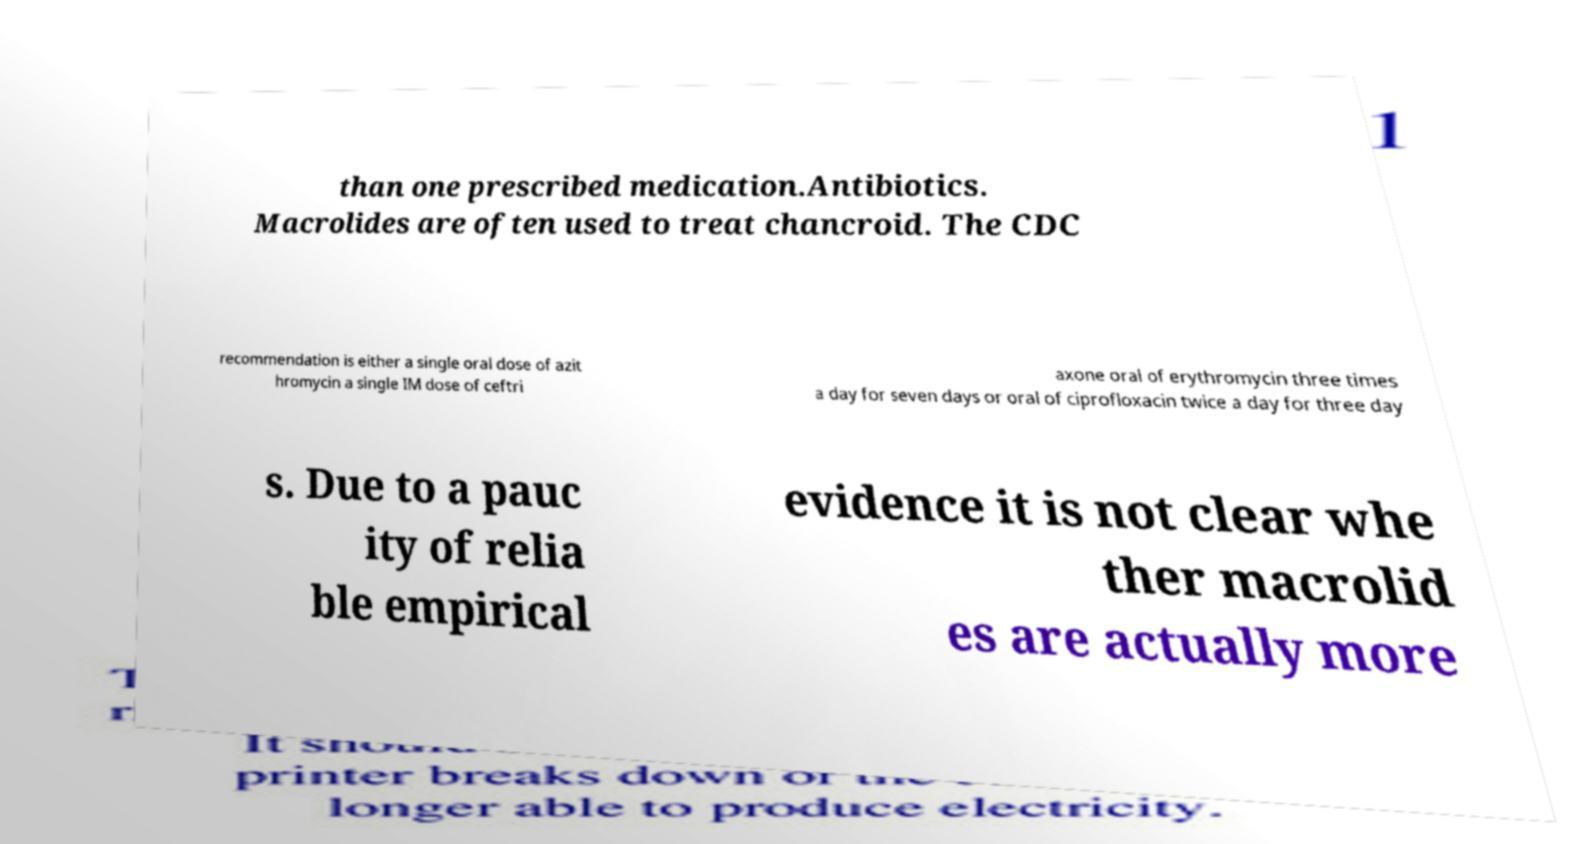Please identify and transcribe the text found in this image. than one prescribed medication.Antibiotics. Macrolides are often used to treat chancroid. The CDC recommendation is either a single oral dose of azit hromycin a single IM dose of ceftri axone oral of erythromycin three times a day for seven days or oral of ciprofloxacin twice a day for three day s. Due to a pauc ity of relia ble empirical evidence it is not clear whe ther macrolid es are actually more 